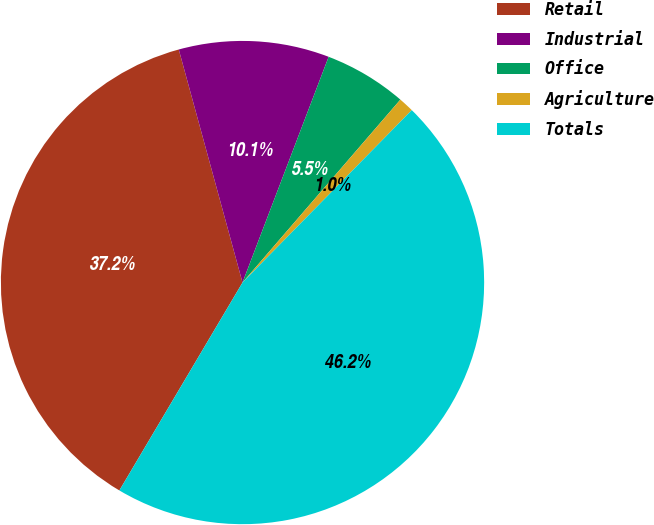Convert chart. <chart><loc_0><loc_0><loc_500><loc_500><pie_chart><fcel>Retail<fcel>Industrial<fcel>Office<fcel>Agriculture<fcel>Totals<nl><fcel>37.24%<fcel>10.05%<fcel>5.53%<fcel>1.02%<fcel>46.16%<nl></chart> 